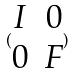Convert formula to latex. <formula><loc_0><loc_0><loc_500><loc_500>( \begin{matrix} I & 0 \\ 0 & F \end{matrix} )</formula> 